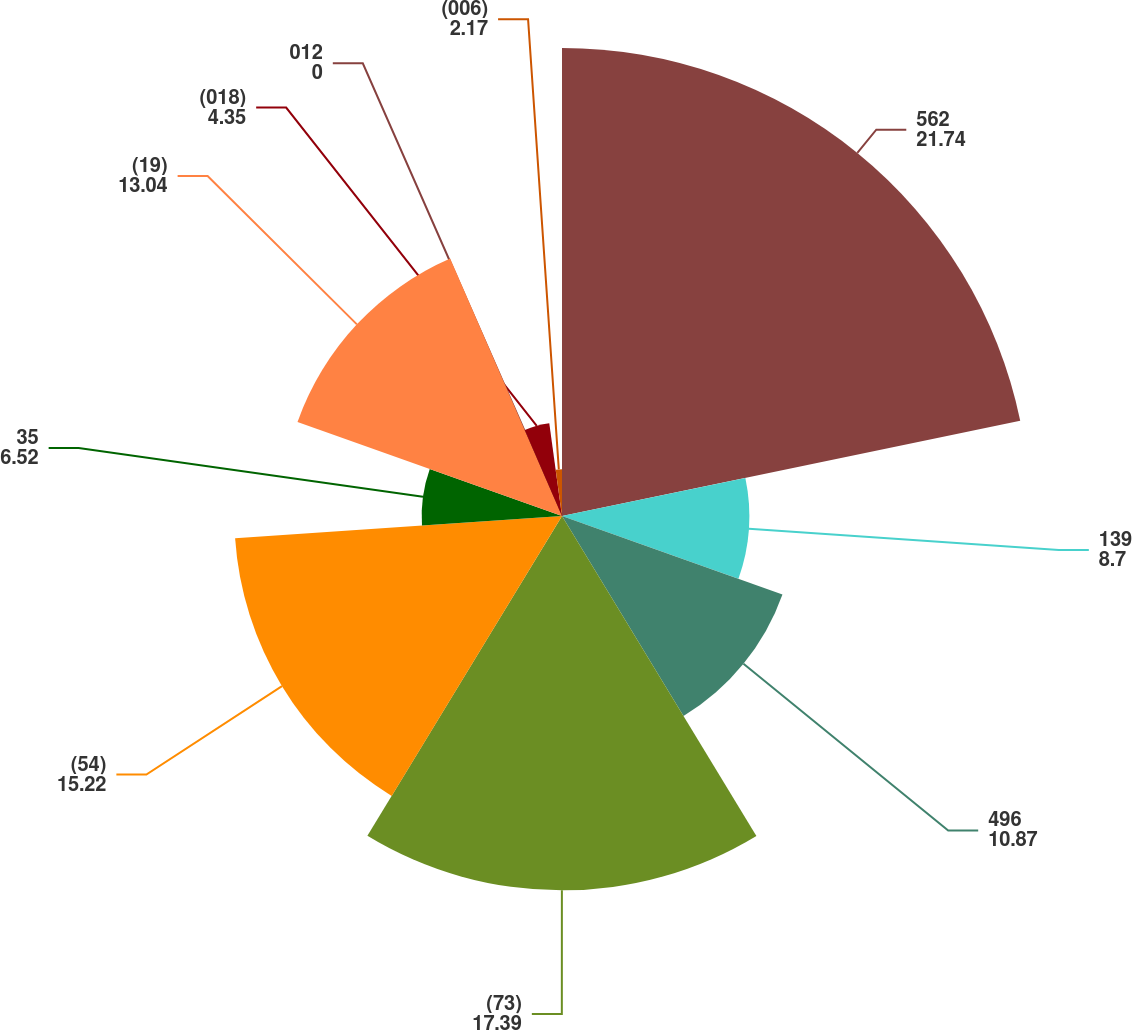Convert chart. <chart><loc_0><loc_0><loc_500><loc_500><pie_chart><fcel>562<fcel>139<fcel>496<fcel>(73)<fcel>(54)<fcel>35<fcel>(19)<fcel>(018)<fcel>012<fcel>(006)<nl><fcel>21.74%<fcel>8.7%<fcel>10.87%<fcel>17.39%<fcel>15.22%<fcel>6.52%<fcel>13.04%<fcel>4.35%<fcel>0.0%<fcel>2.17%<nl></chart> 